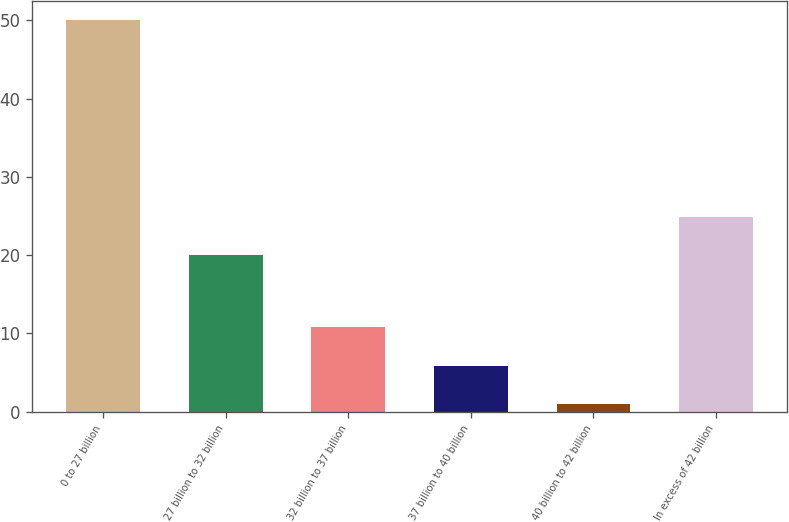<chart> <loc_0><loc_0><loc_500><loc_500><bar_chart><fcel>0 to 27 billion<fcel>27 billion to 32 billion<fcel>32 billion to 37 billion<fcel>37 billion to 40 billion<fcel>40 billion to 42 billion<fcel>In excess of 42 billion<nl><fcel>50<fcel>20<fcel>10.8<fcel>5.9<fcel>1<fcel>24.9<nl></chart> 